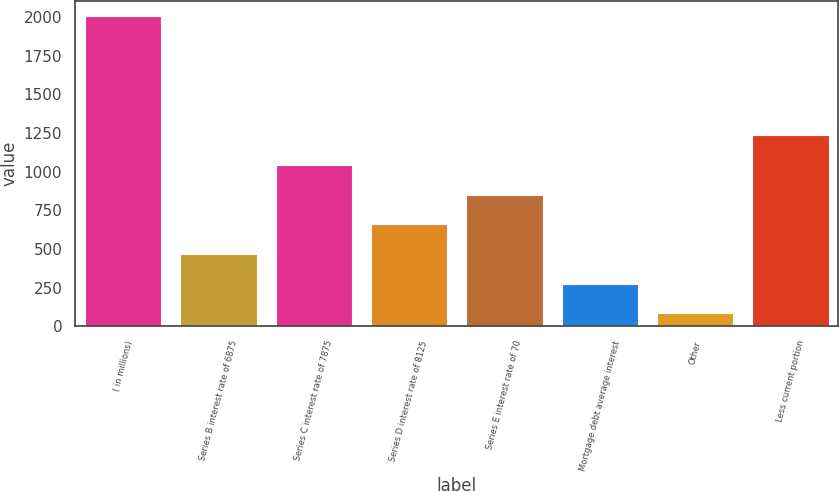Convert chart to OTSL. <chart><loc_0><loc_0><loc_500><loc_500><bar_chart><fcel>( in millions)<fcel>Series B interest rate of 6875<fcel>Series C interest rate of 7875<fcel>Series D interest rate of 8125<fcel>Series E interest rate of 70<fcel>Mortgage debt average interest<fcel>Other<fcel>Less current portion<nl><fcel>2004<fcel>468<fcel>1044<fcel>660<fcel>852<fcel>276<fcel>84<fcel>1236<nl></chart> 